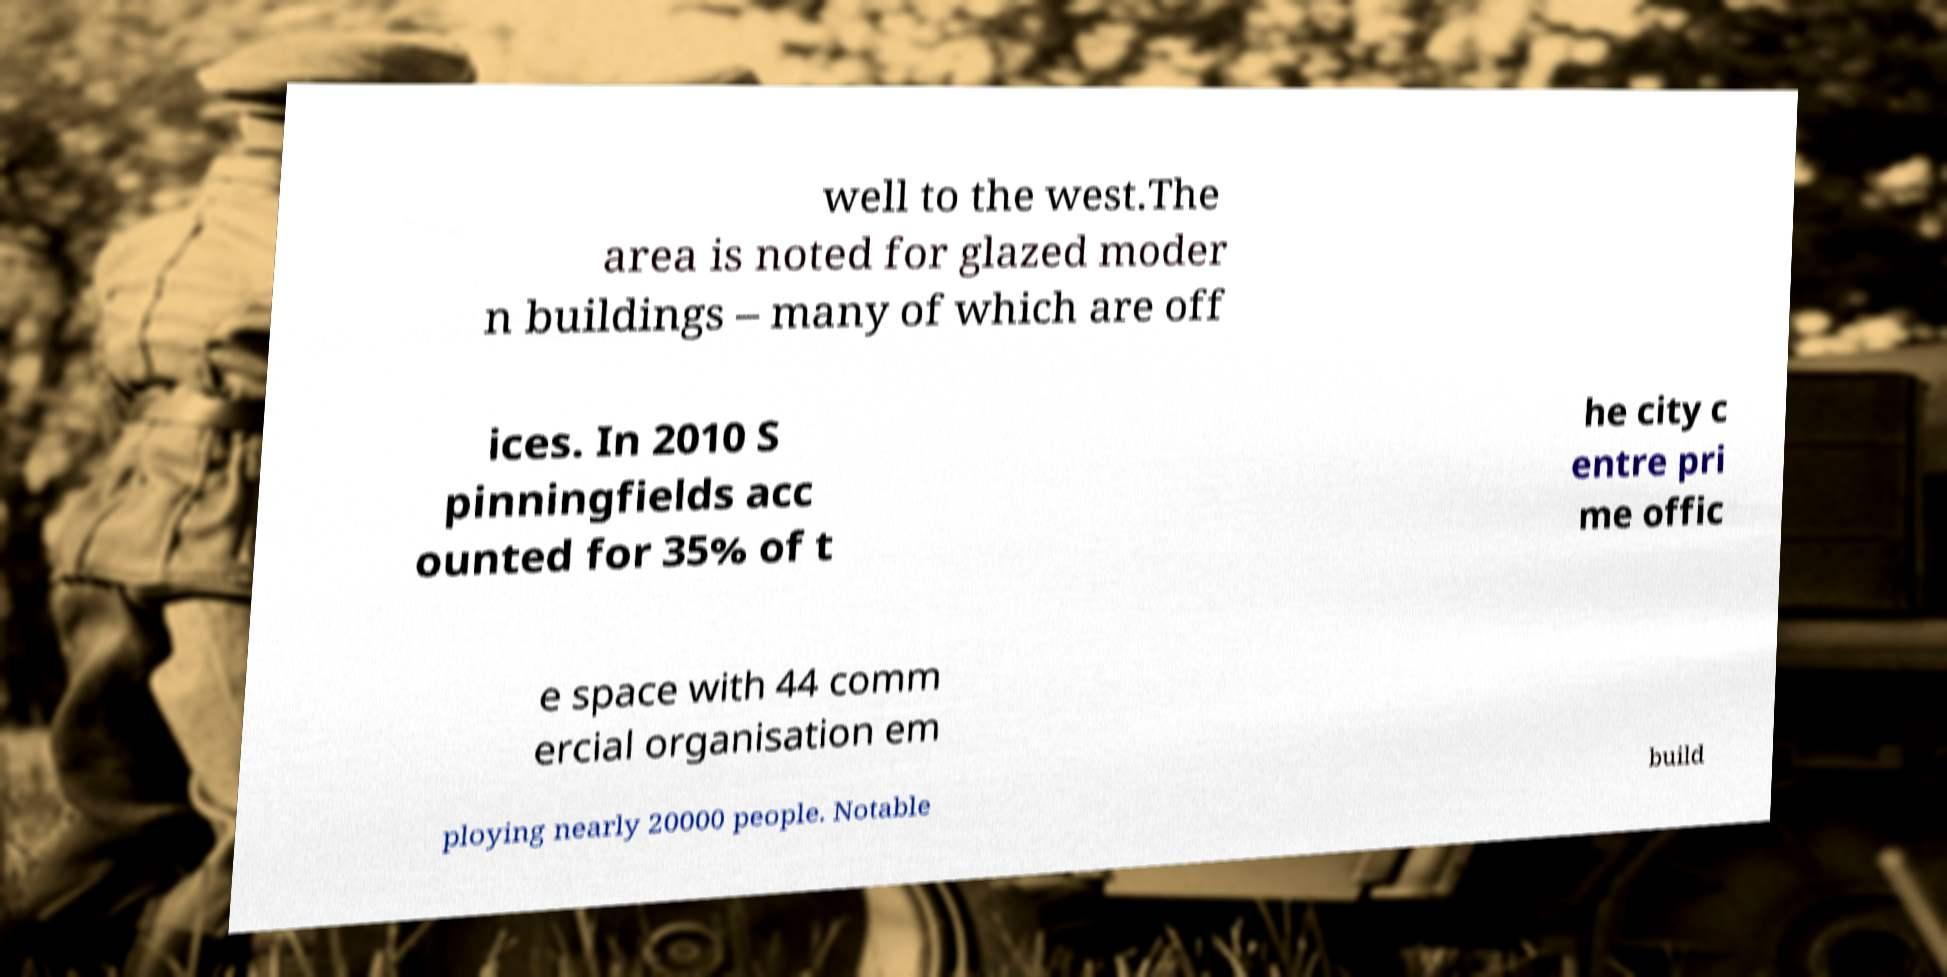There's text embedded in this image that I need extracted. Can you transcribe it verbatim? well to the west.The area is noted for glazed moder n buildings – many of which are off ices. In 2010 S pinningfields acc ounted for 35% of t he city c entre pri me offic e space with 44 comm ercial organisation em ploying nearly 20000 people. Notable build 